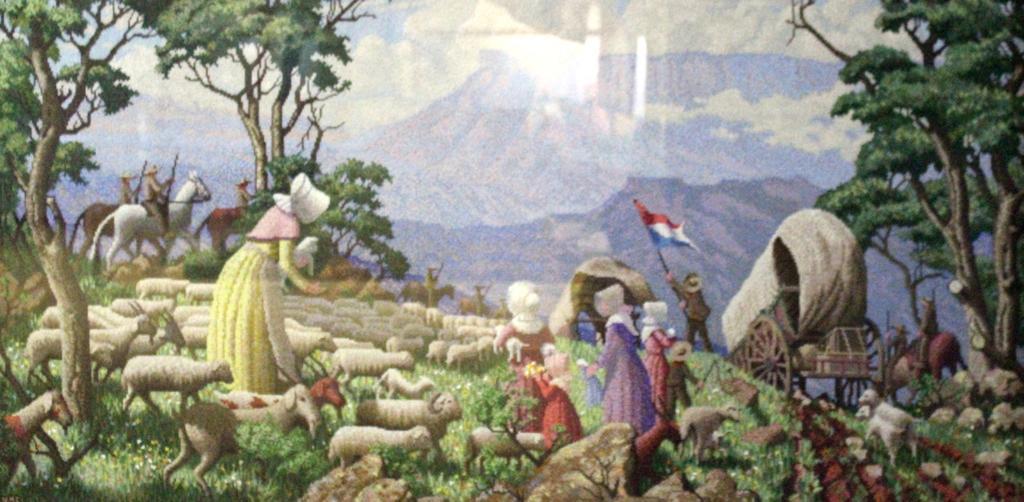Could you give a brief overview of what you see in this image? It is a painting, in the painting we can see some sheeps and people and cart. Behind them few people are riding horses and there are some trees. 